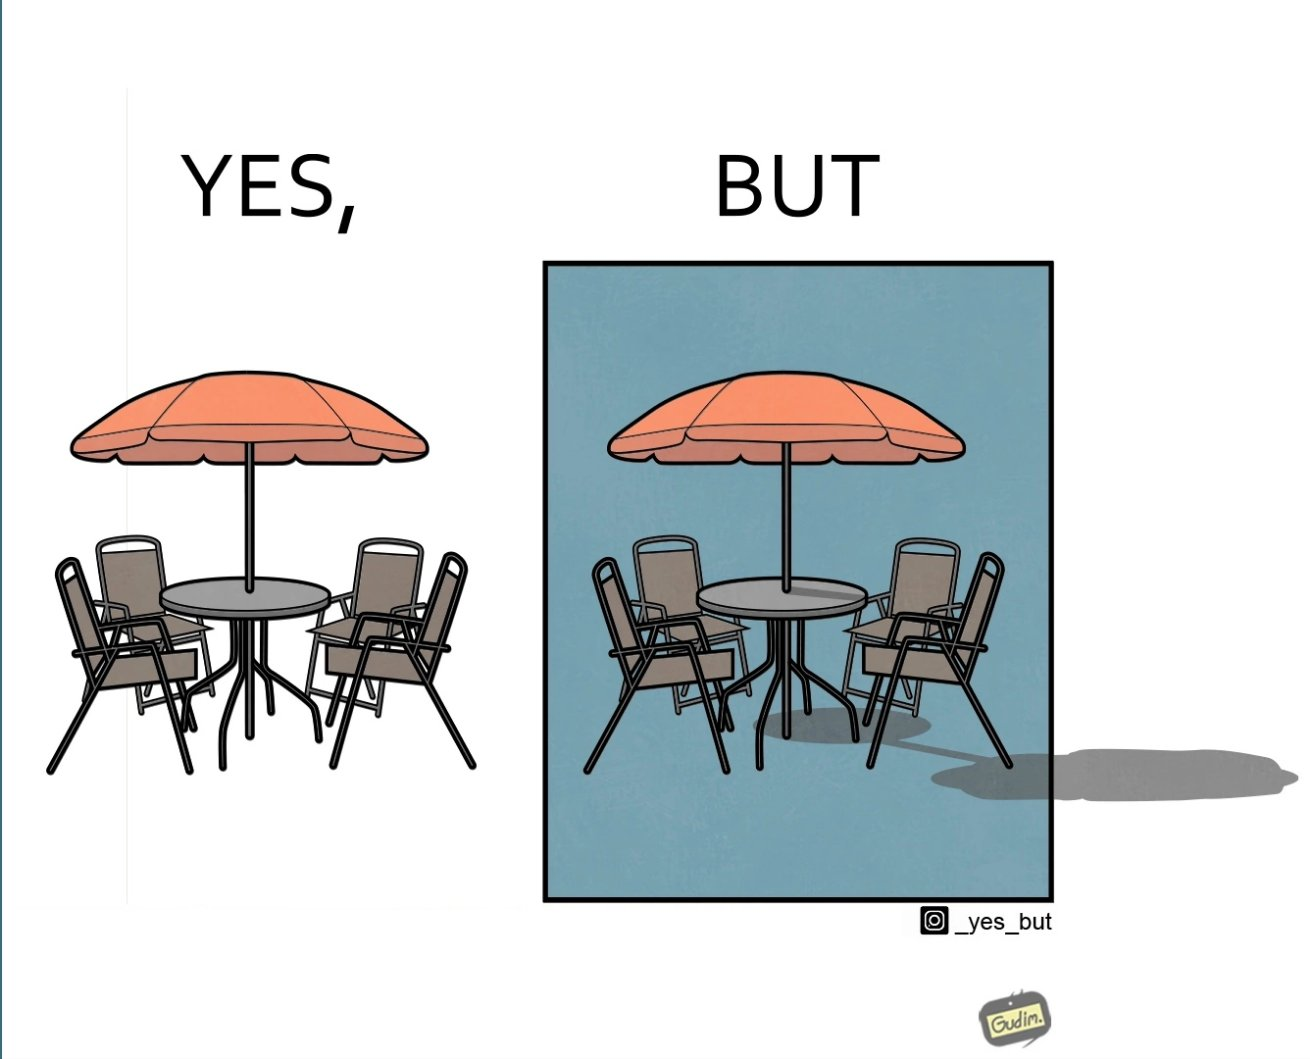Compare the left and right sides of this image. In the left part of the image: Chairs surrounding a table under a large umbrella. In the right part of the image: Chairs surrounding a table under a large umbrella, with the shadow of the umbrella appearing on the side. 